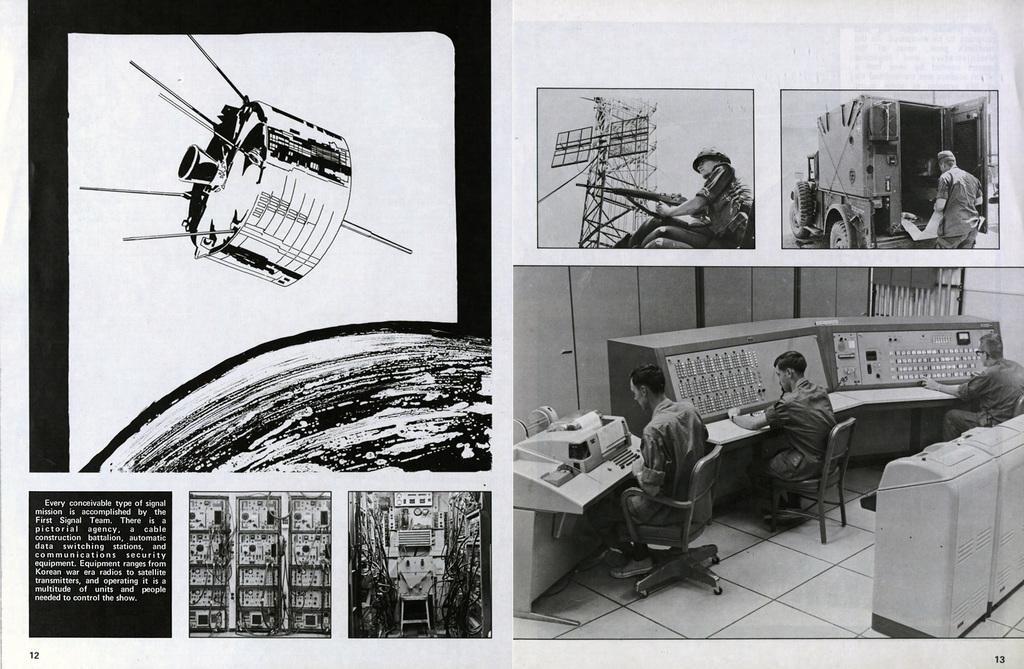Describe this image in one or two sentences. In this college,there are some images. There is a image of satellite revolving around earth. Below it there are some images of equipment with description. Beside it there is a soldier with communication tower. In one a soldier is carrying out something from a vehicle. There is another image of people working. 